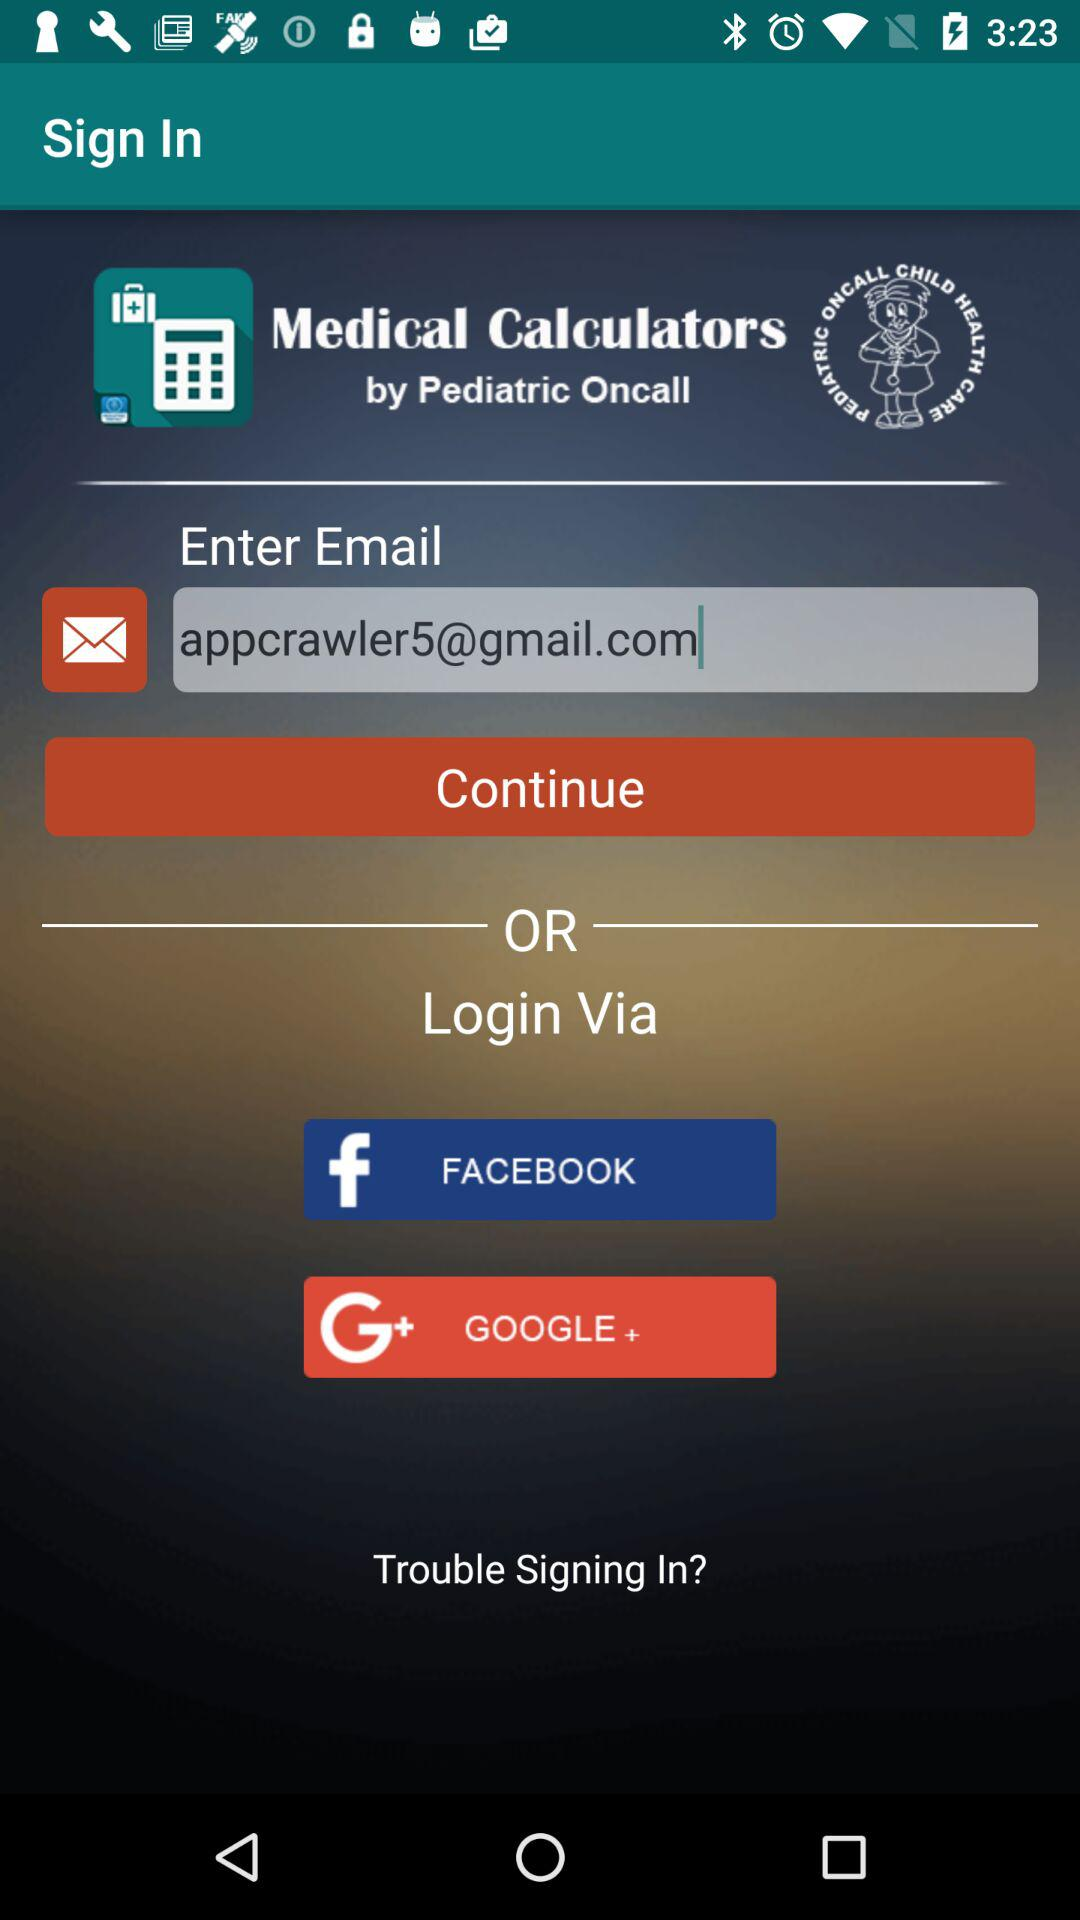What email address is used? The used email address is appcrawler5@gmail.com. 